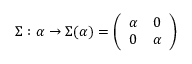<formula> <loc_0><loc_0><loc_500><loc_500>\Sigma \colon \alpha \rightarrow \Sigma ( \alpha ) = \left ( \begin{array} { c c } { \alpha } & { 0 } \\ { 0 } & { \alpha } \end{array} \right )</formula> 